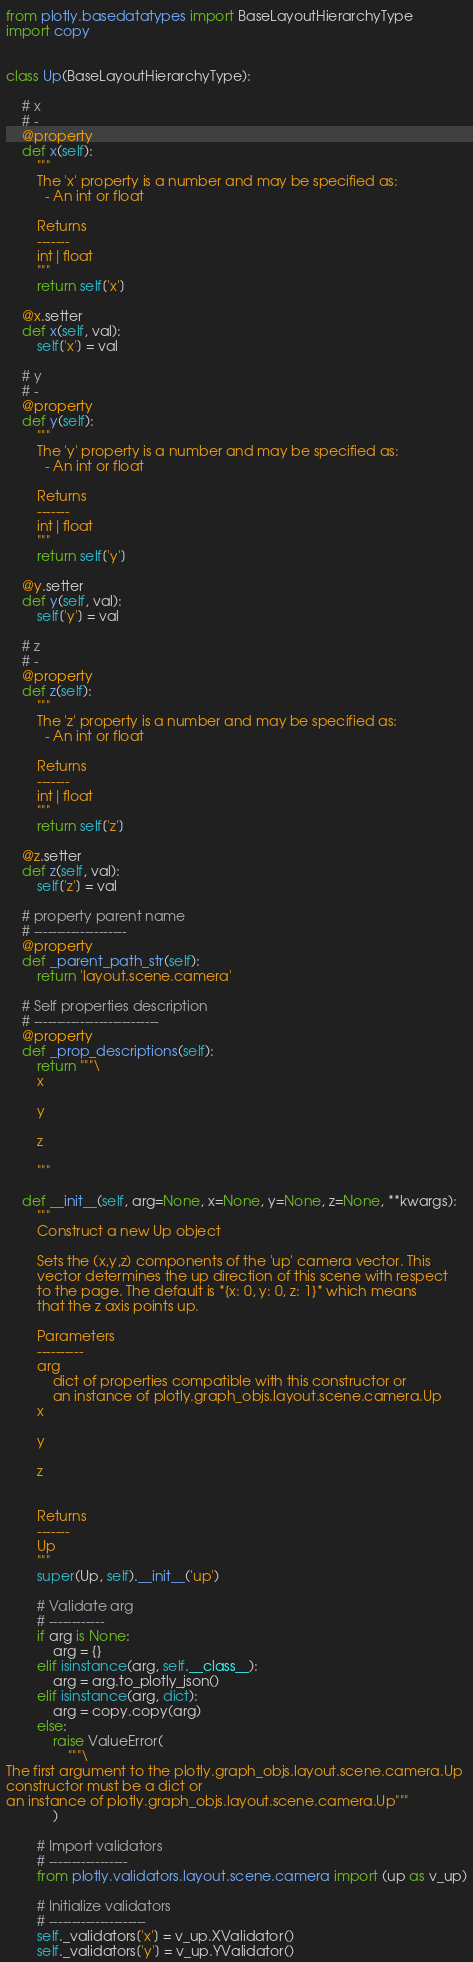Convert code to text. <code><loc_0><loc_0><loc_500><loc_500><_Python_>from plotly.basedatatypes import BaseLayoutHierarchyType
import copy


class Up(BaseLayoutHierarchyType):

    # x
    # -
    @property
    def x(self):
        """
        The 'x' property is a number and may be specified as:
          - An int or float

        Returns
        -------
        int|float
        """
        return self['x']

    @x.setter
    def x(self, val):
        self['x'] = val

    # y
    # -
    @property
    def y(self):
        """
        The 'y' property is a number and may be specified as:
          - An int or float

        Returns
        -------
        int|float
        """
        return self['y']

    @y.setter
    def y(self, val):
        self['y'] = val

    # z
    # -
    @property
    def z(self):
        """
        The 'z' property is a number and may be specified as:
          - An int or float

        Returns
        -------
        int|float
        """
        return self['z']

    @z.setter
    def z(self, val):
        self['z'] = val

    # property parent name
    # --------------------
    @property
    def _parent_path_str(self):
        return 'layout.scene.camera'

    # Self properties description
    # ---------------------------
    @property
    def _prop_descriptions(self):
        return """\
        x

        y

        z

        """

    def __init__(self, arg=None, x=None, y=None, z=None, **kwargs):
        """
        Construct a new Up object
        
        Sets the (x,y,z) components of the 'up' camera vector. This
        vector determines the up direction of this scene with respect
        to the page. The default is *{x: 0, y: 0, z: 1}* which means
        that the z axis points up.

        Parameters
        ----------
        arg
            dict of properties compatible with this constructor or
            an instance of plotly.graph_objs.layout.scene.camera.Up
        x

        y

        z


        Returns
        -------
        Up
        """
        super(Up, self).__init__('up')

        # Validate arg
        # ------------
        if arg is None:
            arg = {}
        elif isinstance(arg, self.__class__):
            arg = arg.to_plotly_json()
        elif isinstance(arg, dict):
            arg = copy.copy(arg)
        else:
            raise ValueError(
                """\
The first argument to the plotly.graph_objs.layout.scene.camera.Up 
constructor must be a dict or 
an instance of plotly.graph_objs.layout.scene.camera.Up"""
            )

        # Import validators
        # -----------------
        from plotly.validators.layout.scene.camera import (up as v_up)

        # Initialize validators
        # ---------------------
        self._validators['x'] = v_up.XValidator()
        self._validators['y'] = v_up.YValidator()</code> 